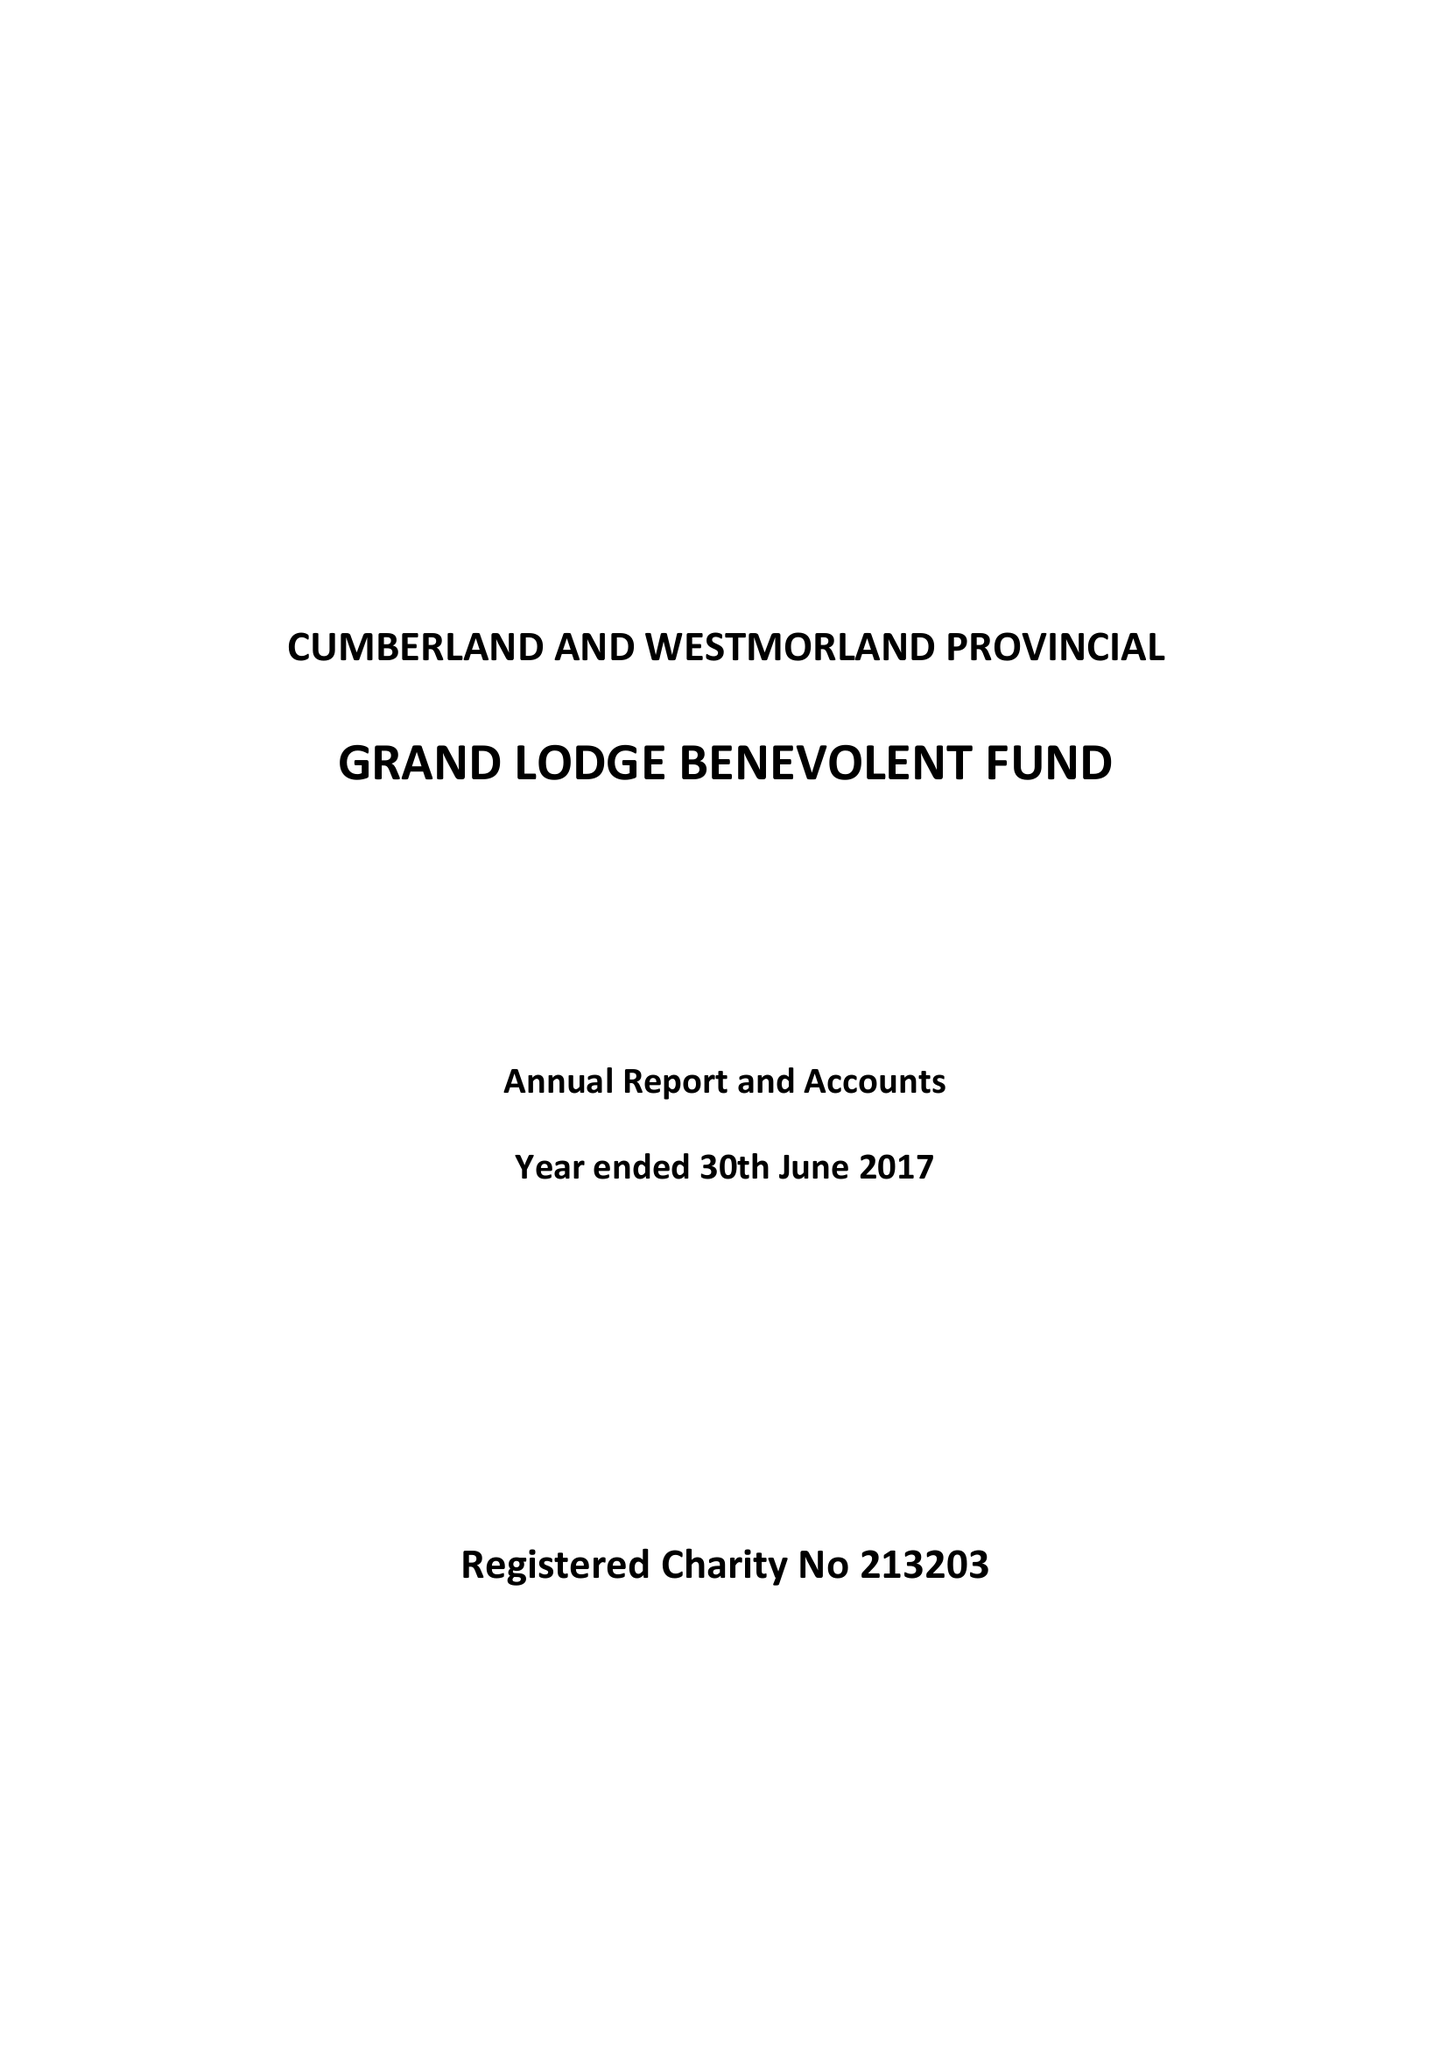What is the value for the spending_annually_in_british_pounds?
Answer the question using a single word or phrase. 47111.00 